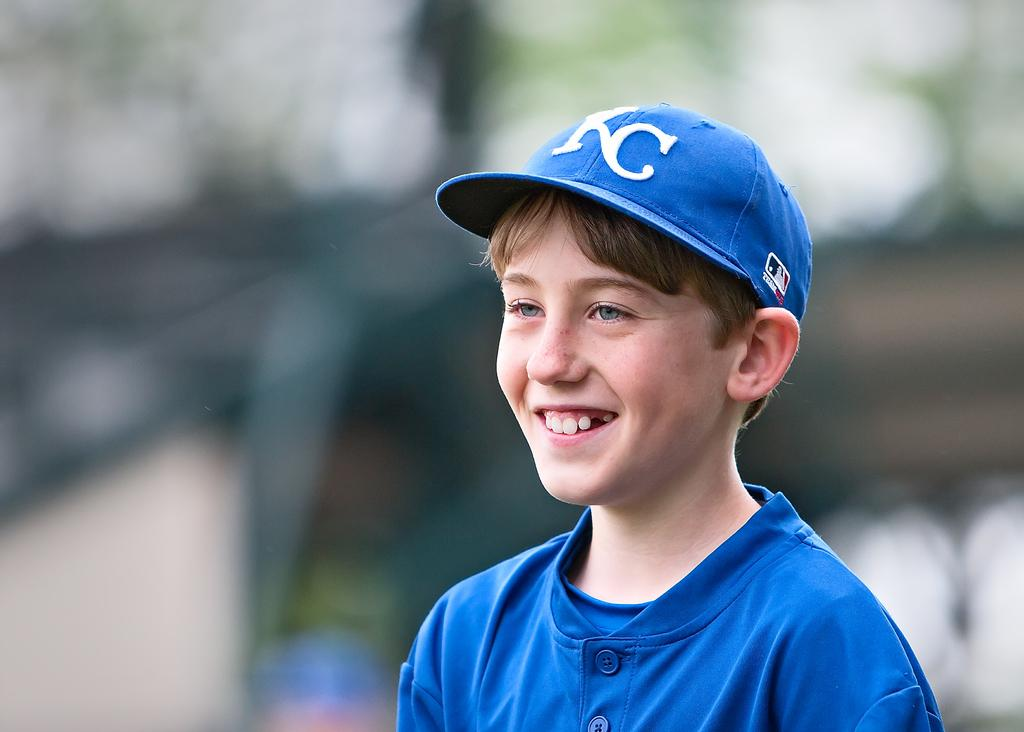What can be observed about the background of the image? The background of the picture is blurred. Who is the main subject in the image? There is a boy in the image. What is the boy wearing? The boy is wearing a blue t-shirt and a blue cap. What is the boy's facial expression? The boy is smiling. Is the boy working in the rain in the image? There is no indication of work or rain in the image; it only shows a boy wearing a blue t-shirt, blue cap, and smiling. 